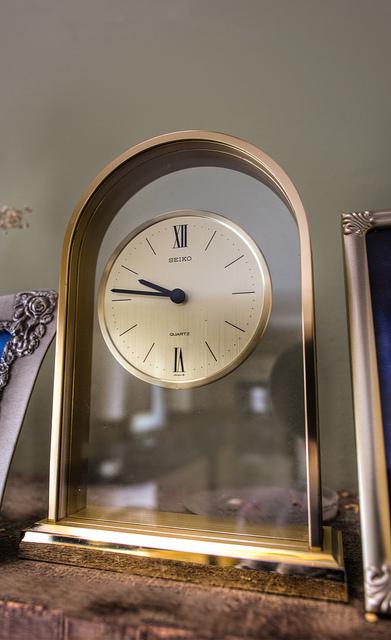What color is the clock?
Write a very short answer. Gold. What number does the hour hand point to?
Write a very short answer. 10. What color is the clock?
Answer briefly. Gold. Is the clocks frame wooden?
Give a very brief answer. No. What is the clock made of?
Concise answer only. Glass. What time is there on the clock?
Write a very short answer. 9:46. What time is the clock saying?
Be succinct. 9:46. 